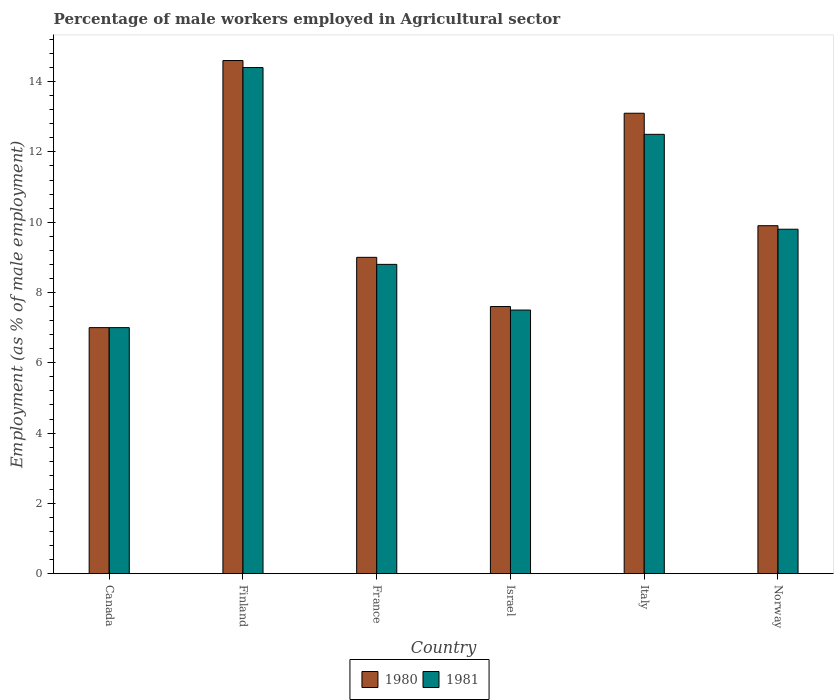How many different coloured bars are there?
Offer a very short reply. 2. How many groups of bars are there?
Provide a short and direct response. 6. How many bars are there on the 4th tick from the left?
Offer a terse response. 2. What is the label of the 6th group of bars from the left?
Offer a terse response. Norway. In how many cases, is the number of bars for a given country not equal to the number of legend labels?
Give a very brief answer. 0. Across all countries, what is the maximum percentage of male workers employed in Agricultural sector in 1981?
Your answer should be compact. 14.4. In which country was the percentage of male workers employed in Agricultural sector in 1980 minimum?
Your response must be concise. Canada. What is the total percentage of male workers employed in Agricultural sector in 1981 in the graph?
Your answer should be compact. 60. What is the difference between the percentage of male workers employed in Agricultural sector in 1980 in France and that in Israel?
Your answer should be compact. 1.4. What is the difference between the percentage of male workers employed in Agricultural sector in 1980 in France and the percentage of male workers employed in Agricultural sector in 1981 in Israel?
Ensure brevity in your answer.  1.5. What is the average percentage of male workers employed in Agricultural sector in 1980 per country?
Keep it short and to the point. 10.2. What is the difference between the percentage of male workers employed in Agricultural sector of/in 1980 and percentage of male workers employed in Agricultural sector of/in 1981 in Norway?
Your answer should be compact. 0.1. In how many countries, is the percentage of male workers employed in Agricultural sector in 1981 greater than 2 %?
Provide a short and direct response. 6. What is the ratio of the percentage of male workers employed in Agricultural sector in 1980 in Finland to that in Norway?
Keep it short and to the point. 1.47. Is the difference between the percentage of male workers employed in Agricultural sector in 1980 in Israel and Norway greater than the difference between the percentage of male workers employed in Agricultural sector in 1981 in Israel and Norway?
Make the answer very short. Yes. What is the difference between the highest and the second highest percentage of male workers employed in Agricultural sector in 1980?
Offer a very short reply. -3.2. What is the difference between the highest and the lowest percentage of male workers employed in Agricultural sector in 1980?
Keep it short and to the point. 7.6. In how many countries, is the percentage of male workers employed in Agricultural sector in 1980 greater than the average percentage of male workers employed in Agricultural sector in 1980 taken over all countries?
Offer a terse response. 2. What does the 1st bar from the right in Italy represents?
Your response must be concise. 1981. How many bars are there?
Provide a short and direct response. 12. How many countries are there in the graph?
Your answer should be compact. 6. What is the difference between two consecutive major ticks on the Y-axis?
Provide a succinct answer. 2. Does the graph contain any zero values?
Your answer should be compact. No. Does the graph contain grids?
Give a very brief answer. No. Where does the legend appear in the graph?
Offer a very short reply. Bottom center. How many legend labels are there?
Your answer should be very brief. 2. What is the title of the graph?
Your answer should be compact. Percentage of male workers employed in Agricultural sector. Does "1960" appear as one of the legend labels in the graph?
Keep it short and to the point. No. What is the label or title of the Y-axis?
Your answer should be compact. Employment (as % of male employment). What is the Employment (as % of male employment) in 1980 in Canada?
Your answer should be compact. 7. What is the Employment (as % of male employment) in 1980 in Finland?
Your answer should be compact. 14.6. What is the Employment (as % of male employment) of 1981 in Finland?
Make the answer very short. 14.4. What is the Employment (as % of male employment) of 1980 in France?
Your response must be concise. 9. What is the Employment (as % of male employment) of 1981 in France?
Give a very brief answer. 8.8. What is the Employment (as % of male employment) in 1980 in Israel?
Your answer should be very brief. 7.6. What is the Employment (as % of male employment) of 1980 in Italy?
Ensure brevity in your answer.  13.1. What is the Employment (as % of male employment) of 1980 in Norway?
Provide a short and direct response. 9.9. What is the Employment (as % of male employment) of 1981 in Norway?
Your response must be concise. 9.8. Across all countries, what is the maximum Employment (as % of male employment) of 1980?
Give a very brief answer. 14.6. Across all countries, what is the maximum Employment (as % of male employment) in 1981?
Provide a short and direct response. 14.4. Across all countries, what is the minimum Employment (as % of male employment) of 1980?
Your response must be concise. 7. What is the total Employment (as % of male employment) of 1980 in the graph?
Make the answer very short. 61.2. What is the total Employment (as % of male employment) of 1981 in the graph?
Give a very brief answer. 60. What is the difference between the Employment (as % of male employment) in 1980 in Canada and that in Finland?
Provide a succinct answer. -7.6. What is the difference between the Employment (as % of male employment) of 1981 in Canada and that in Israel?
Offer a terse response. -0.5. What is the difference between the Employment (as % of male employment) in 1981 in Canada and that in Italy?
Keep it short and to the point. -5.5. What is the difference between the Employment (as % of male employment) in 1981 in Canada and that in Norway?
Ensure brevity in your answer.  -2.8. What is the difference between the Employment (as % of male employment) of 1981 in Finland and that in France?
Your answer should be compact. 5.6. What is the difference between the Employment (as % of male employment) of 1980 in Finland and that in Israel?
Your answer should be very brief. 7. What is the difference between the Employment (as % of male employment) of 1980 in Finland and that in Italy?
Give a very brief answer. 1.5. What is the difference between the Employment (as % of male employment) in 1980 in France and that in Israel?
Provide a short and direct response. 1.4. What is the difference between the Employment (as % of male employment) in 1981 in France and that in Israel?
Your response must be concise. 1.3. What is the difference between the Employment (as % of male employment) of 1981 in France and that in Italy?
Your answer should be very brief. -3.7. What is the difference between the Employment (as % of male employment) in 1981 in France and that in Norway?
Offer a terse response. -1. What is the difference between the Employment (as % of male employment) of 1980 in Israel and that in Norway?
Offer a very short reply. -2.3. What is the difference between the Employment (as % of male employment) in 1981 in Israel and that in Norway?
Offer a terse response. -2.3. What is the difference between the Employment (as % of male employment) of 1980 in Italy and that in Norway?
Ensure brevity in your answer.  3.2. What is the difference between the Employment (as % of male employment) in 1980 in Canada and the Employment (as % of male employment) in 1981 in Finland?
Provide a short and direct response. -7.4. What is the difference between the Employment (as % of male employment) of 1980 in Canada and the Employment (as % of male employment) of 1981 in Italy?
Offer a very short reply. -5.5. What is the difference between the Employment (as % of male employment) of 1980 in Finland and the Employment (as % of male employment) of 1981 in France?
Keep it short and to the point. 5.8. What is the difference between the Employment (as % of male employment) in 1980 in Finland and the Employment (as % of male employment) in 1981 in Italy?
Provide a short and direct response. 2.1. What is the difference between the Employment (as % of male employment) in 1980 in Finland and the Employment (as % of male employment) in 1981 in Norway?
Provide a short and direct response. 4.8. What is the difference between the Employment (as % of male employment) of 1980 in Israel and the Employment (as % of male employment) of 1981 in Italy?
Ensure brevity in your answer.  -4.9. What is the difference between the Employment (as % of male employment) in 1980 in Italy and the Employment (as % of male employment) in 1981 in Norway?
Make the answer very short. 3.3. What is the difference between the Employment (as % of male employment) in 1980 and Employment (as % of male employment) in 1981 in Canada?
Your response must be concise. 0. What is the difference between the Employment (as % of male employment) of 1980 and Employment (as % of male employment) of 1981 in Finland?
Give a very brief answer. 0.2. What is the difference between the Employment (as % of male employment) in 1980 and Employment (as % of male employment) in 1981 in France?
Make the answer very short. 0.2. What is the difference between the Employment (as % of male employment) in 1980 and Employment (as % of male employment) in 1981 in Israel?
Make the answer very short. 0.1. What is the difference between the Employment (as % of male employment) in 1980 and Employment (as % of male employment) in 1981 in Italy?
Your response must be concise. 0.6. What is the difference between the Employment (as % of male employment) in 1980 and Employment (as % of male employment) in 1981 in Norway?
Offer a terse response. 0.1. What is the ratio of the Employment (as % of male employment) in 1980 in Canada to that in Finland?
Your response must be concise. 0.48. What is the ratio of the Employment (as % of male employment) of 1981 in Canada to that in Finland?
Keep it short and to the point. 0.49. What is the ratio of the Employment (as % of male employment) in 1981 in Canada to that in France?
Your answer should be compact. 0.8. What is the ratio of the Employment (as % of male employment) in 1980 in Canada to that in Israel?
Ensure brevity in your answer.  0.92. What is the ratio of the Employment (as % of male employment) of 1981 in Canada to that in Israel?
Ensure brevity in your answer.  0.93. What is the ratio of the Employment (as % of male employment) of 1980 in Canada to that in Italy?
Your answer should be very brief. 0.53. What is the ratio of the Employment (as % of male employment) in 1981 in Canada to that in Italy?
Provide a short and direct response. 0.56. What is the ratio of the Employment (as % of male employment) of 1980 in Canada to that in Norway?
Your answer should be compact. 0.71. What is the ratio of the Employment (as % of male employment) in 1980 in Finland to that in France?
Give a very brief answer. 1.62. What is the ratio of the Employment (as % of male employment) of 1981 in Finland to that in France?
Ensure brevity in your answer.  1.64. What is the ratio of the Employment (as % of male employment) in 1980 in Finland to that in Israel?
Give a very brief answer. 1.92. What is the ratio of the Employment (as % of male employment) in 1981 in Finland to that in Israel?
Ensure brevity in your answer.  1.92. What is the ratio of the Employment (as % of male employment) of 1980 in Finland to that in Italy?
Your response must be concise. 1.11. What is the ratio of the Employment (as % of male employment) of 1981 in Finland to that in Italy?
Provide a short and direct response. 1.15. What is the ratio of the Employment (as % of male employment) of 1980 in Finland to that in Norway?
Offer a very short reply. 1.47. What is the ratio of the Employment (as % of male employment) in 1981 in Finland to that in Norway?
Ensure brevity in your answer.  1.47. What is the ratio of the Employment (as % of male employment) of 1980 in France to that in Israel?
Your answer should be very brief. 1.18. What is the ratio of the Employment (as % of male employment) of 1981 in France to that in Israel?
Give a very brief answer. 1.17. What is the ratio of the Employment (as % of male employment) of 1980 in France to that in Italy?
Offer a terse response. 0.69. What is the ratio of the Employment (as % of male employment) in 1981 in France to that in Italy?
Offer a terse response. 0.7. What is the ratio of the Employment (as % of male employment) in 1981 in France to that in Norway?
Offer a terse response. 0.9. What is the ratio of the Employment (as % of male employment) in 1980 in Israel to that in Italy?
Make the answer very short. 0.58. What is the ratio of the Employment (as % of male employment) in 1980 in Israel to that in Norway?
Offer a terse response. 0.77. What is the ratio of the Employment (as % of male employment) of 1981 in Israel to that in Norway?
Offer a terse response. 0.77. What is the ratio of the Employment (as % of male employment) of 1980 in Italy to that in Norway?
Provide a succinct answer. 1.32. What is the ratio of the Employment (as % of male employment) of 1981 in Italy to that in Norway?
Your answer should be compact. 1.28. What is the difference between the highest and the lowest Employment (as % of male employment) in 1980?
Offer a very short reply. 7.6. 